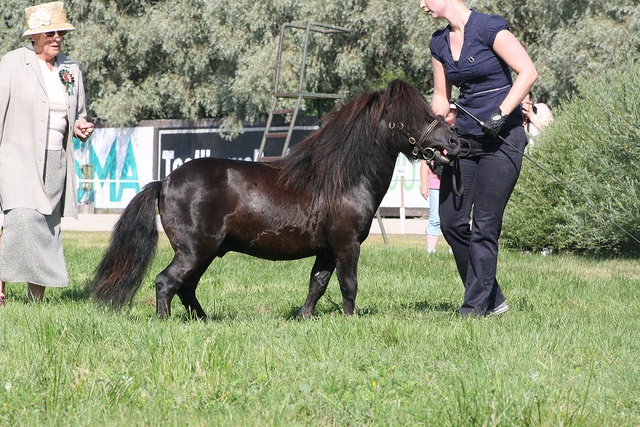Describe the objects in this image and their specific colors. I can see horse in gray and black tones, people in gray, black, and lightgray tones, and people in gray, lightgray, darkgray, and tan tones in this image. 